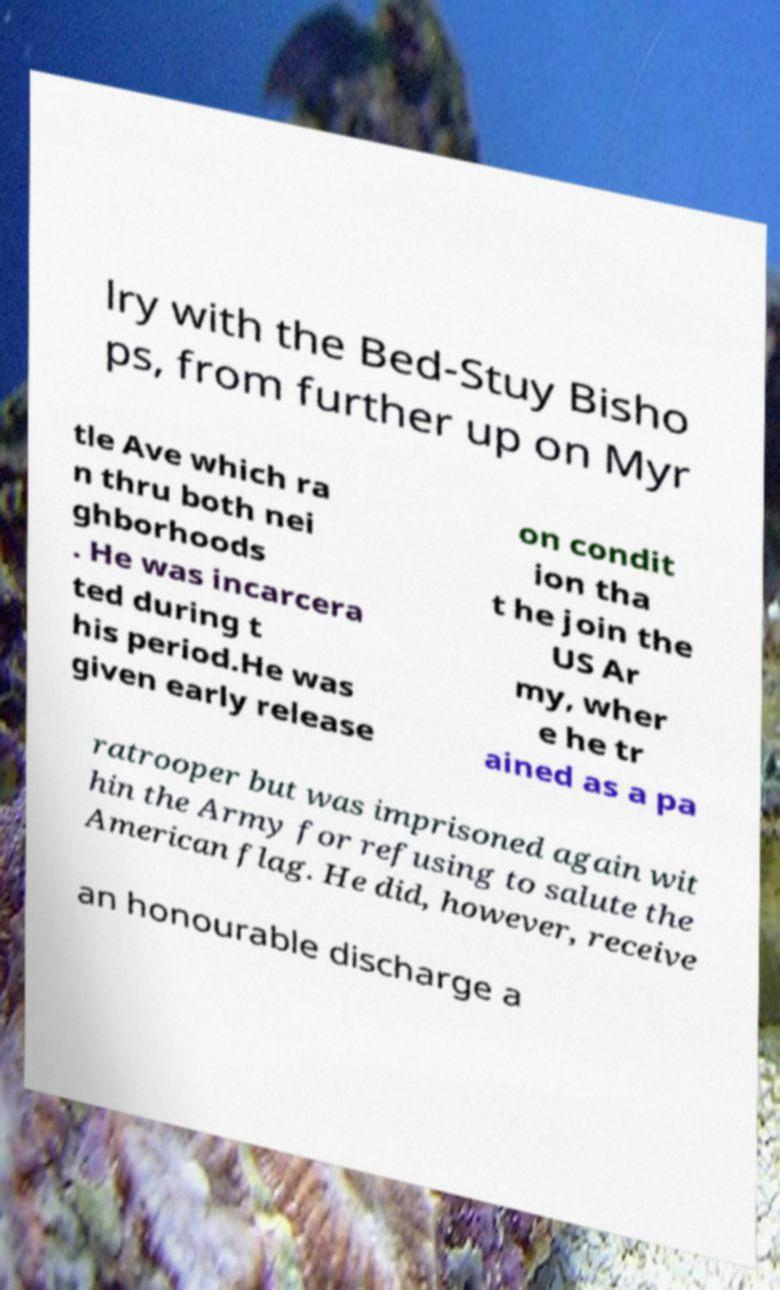What messages or text are displayed in this image? I need them in a readable, typed format. lry with the Bed-Stuy Bisho ps, from further up on Myr tle Ave which ra n thru both nei ghborhoods . He was incarcera ted during t his period.He was given early release on condit ion tha t he join the US Ar my, wher e he tr ained as a pa ratrooper but was imprisoned again wit hin the Army for refusing to salute the American flag. He did, however, receive an honourable discharge a 